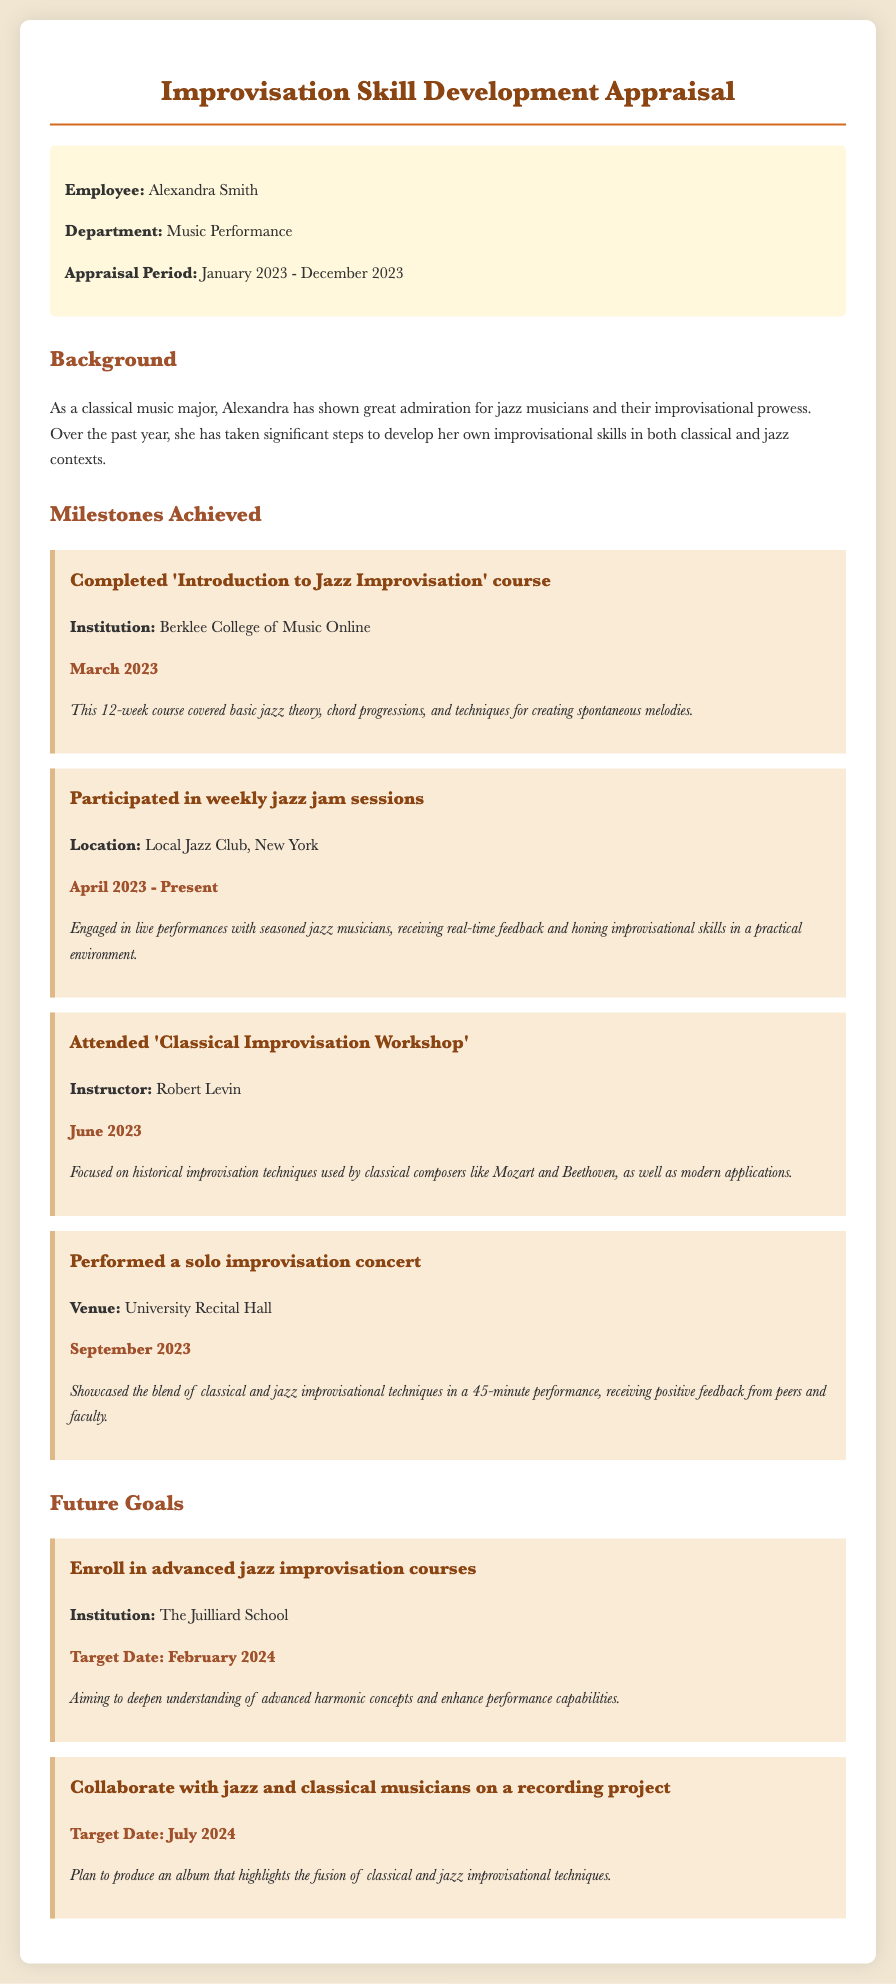What is the name of the employee? The document states the employee's name is Alexandra Smith.
Answer: Alexandra Smith What is the appraisal period? The appraisal period is mentioned at the top of the document, covering the time frame from January to December.
Answer: January 2023 - December 2023 Which institution offered the 'Introduction to Jazz Improvisation' course? The document specifies that the course was offered by Berklee College of Music Online.
Answer: Berklee College of Music Online What date did Alexandra perform her solo improvisation concert? The specific date of the performance is listed in the milestones section of the document.
Answer: September 2023 What is the target date for enrolling in advanced jazz improvisation courses? The target date for this goal is clearly stated in the future goals section.
Answer: February 2024 What was the focus of the Classical Improvisation Workshop attended by Alexandra? This information is outlined in the milestone section, detailing what the workshop covered.
Answer: Historical improvisation techniques How long was the solo improvisation concert? The duration of the performance is provided in the details of the milestone about the concert.
Answer: 45 minutes What type of musicians does Alexandra plan to collaborate with for her recording project? The document mentions the types of musicians involved in the future goal of a recording project.
Answer: Jazz and classical musicians What feedback did Alexandra receive from her solo concert? The document includes feedback from peers and faculty regarding her performance.
Answer: Positive feedback 